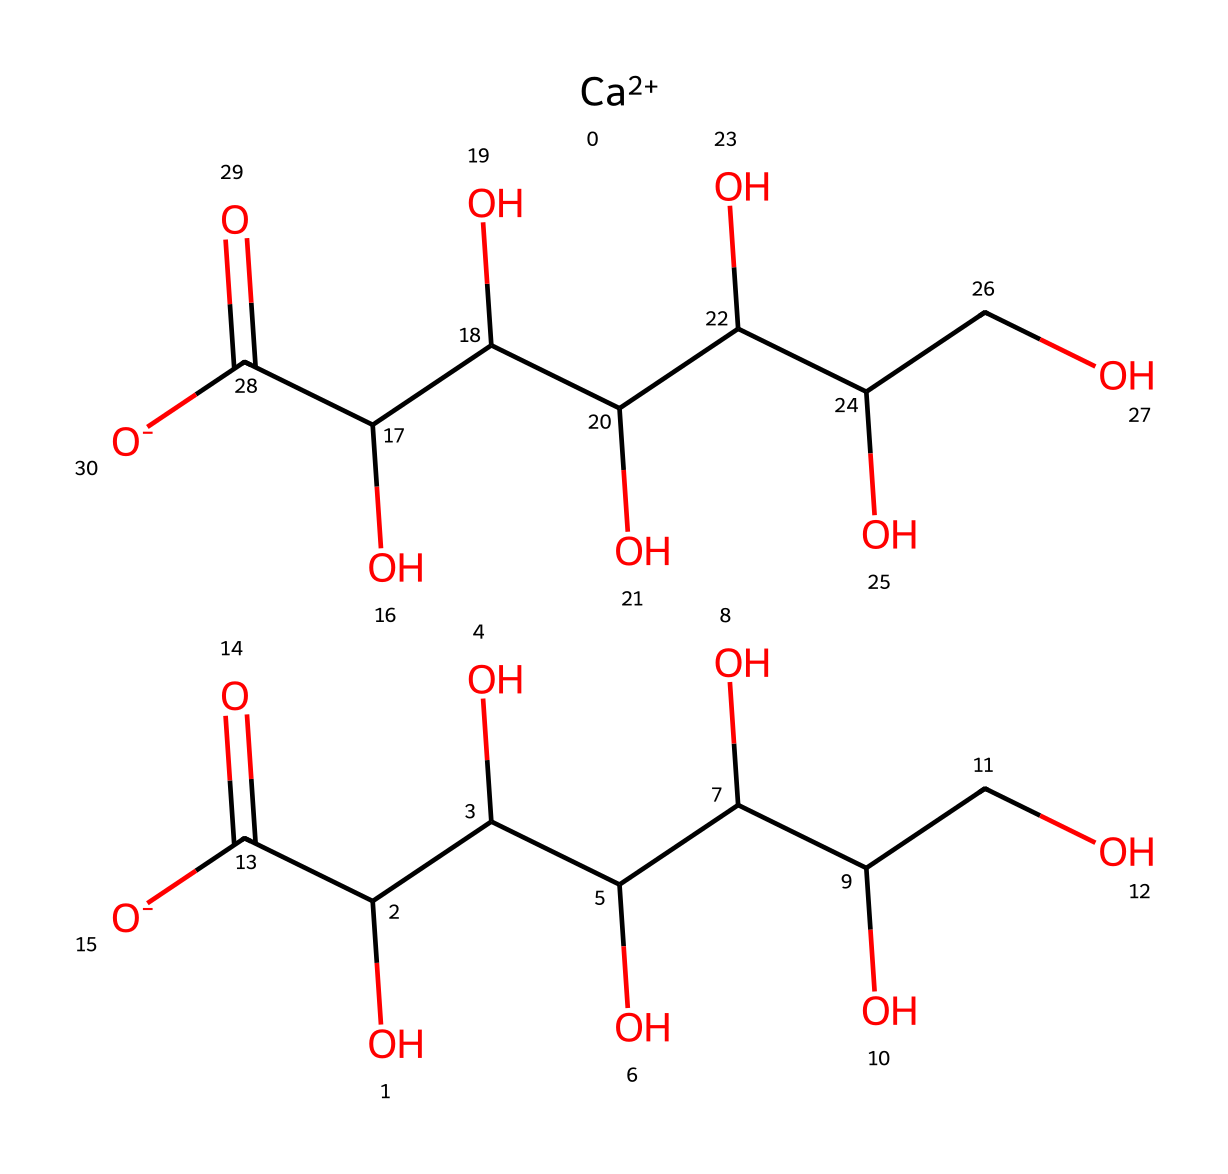What is the chemical name of the compound represented by the SMILES? The SMILES notation represents calcium gluconate, a compound composed of calcium and gluconic acid. The two components are evident in the structure, facilitating the identification of the chemical name.
Answer: calcium gluconate How many carbon atoms are present in the structure? By analyzing the SMILES, we count the carbon (C) atoms in the structure. Each `C` in the representation corresponds directly to one carbon atom, and careful counting shows that there are a total of 12 carbon atoms.
Answer: 12 What is the total number of hydroxyl (-OH) groups in this compound? In the SMILES notation, each -OH group appears as part of a carbon atom's structure. By closely examining the structure, we identify that there are six hydroxyl groups embedded in the structure.
Answer: 6 Is this compound classified as an electrolyte? Calcium gluconate dissociates into calcium ions and gluconate ions in solution, which is characteristic of electrolytes. Thus, due to its ability to conduct electricity when dissolved, it is classified as an electrolyte.
Answer: yes What is the oxidation state of calcium in this compound? Calcium typically exhibits a +2 oxidation state in compounds, which is consistent with the presence of [Ca++] in the SMILES representation showing its ionic form. Therefore, the oxidation state for calcium here is +2.
Answer: +2 Which functional groups are present in calcium gluconate? Analyzing the structure, the main functional groups found here include carboxylic acids (due to the presence of -COOH) and alcohols (due to the presence of -OH groups), which contribute to the properties of calcium gluconate.
Answer: carboxylic acid and alcohol 